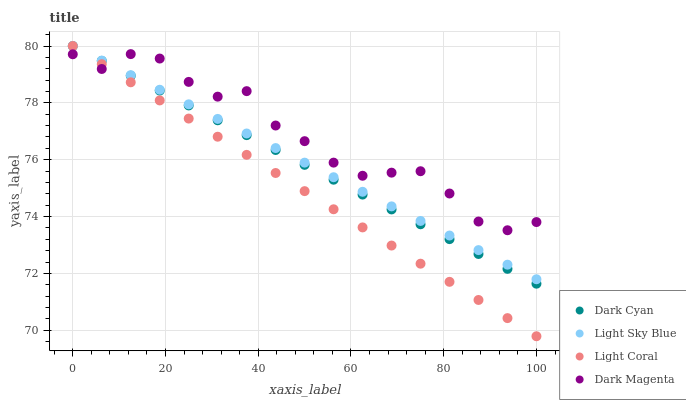Does Light Coral have the minimum area under the curve?
Answer yes or no. Yes. Does Dark Magenta have the maximum area under the curve?
Answer yes or no. Yes. Does Light Sky Blue have the minimum area under the curve?
Answer yes or no. No. Does Light Sky Blue have the maximum area under the curve?
Answer yes or no. No. Is Dark Cyan the smoothest?
Answer yes or no. Yes. Is Dark Magenta the roughest?
Answer yes or no. Yes. Is Light Coral the smoothest?
Answer yes or no. No. Is Light Coral the roughest?
Answer yes or no. No. Does Light Coral have the lowest value?
Answer yes or no. Yes. Does Light Sky Blue have the lowest value?
Answer yes or no. No. Does Light Sky Blue have the highest value?
Answer yes or no. Yes. Does Dark Magenta have the highest value?
Answer yes or no. No. Does Dark Magenta intersect Light Sky Blue?
Answer yes or no. Yes. Is Dark Magenta less than Light Sky Blue?
Answer yes or no. No. Is Dark Magenta greater than Light Sky Blue?
Answer yes or no. No. 